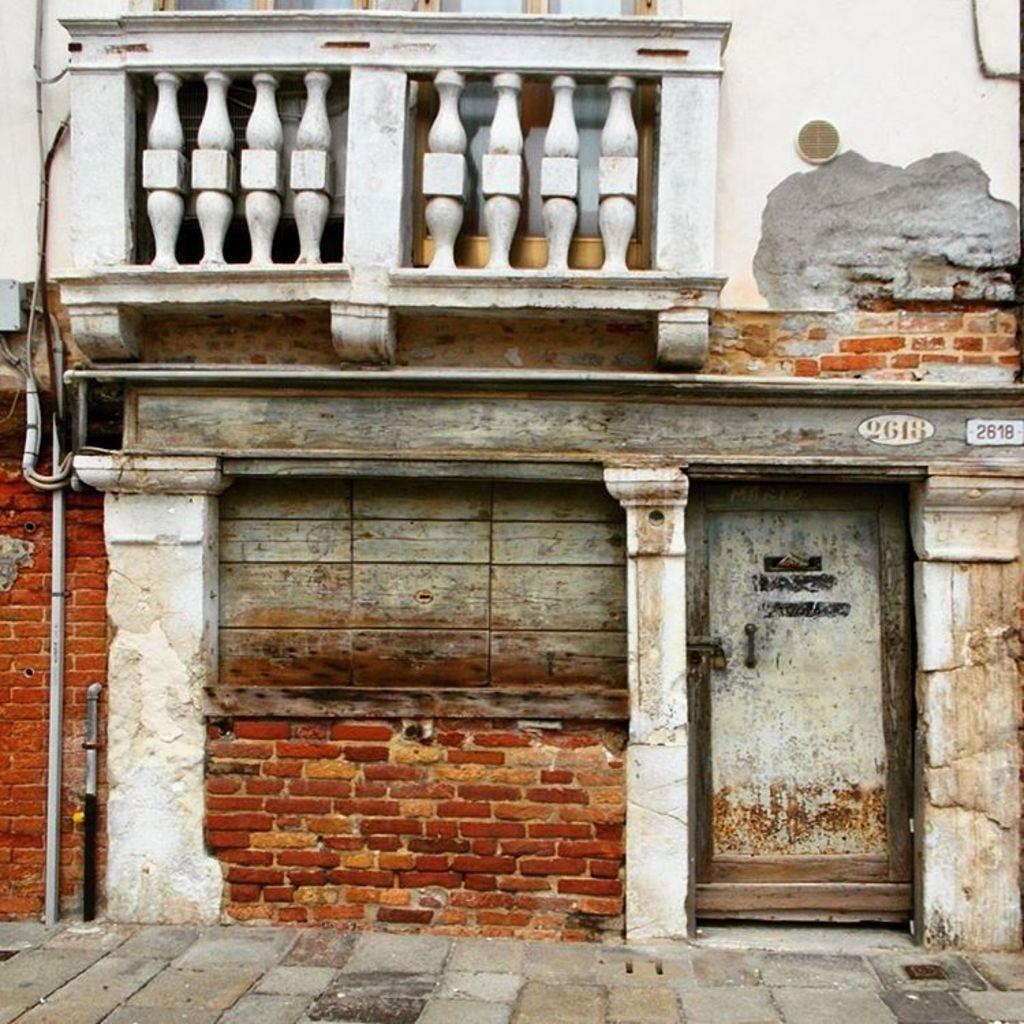What type of structure is present in the image? There is a building in the image. Where is the door located in relation to the building? The door is on the right side of the image. What additional information can be found on the building? Numbers are written on the building. What can be seen in front of the building? There is a path visible in the image. What type of shade is being used to balance the grain in the image? There is no shade or grain present in the image; it features a building with a door and numbers written on it, along with a visible path. 